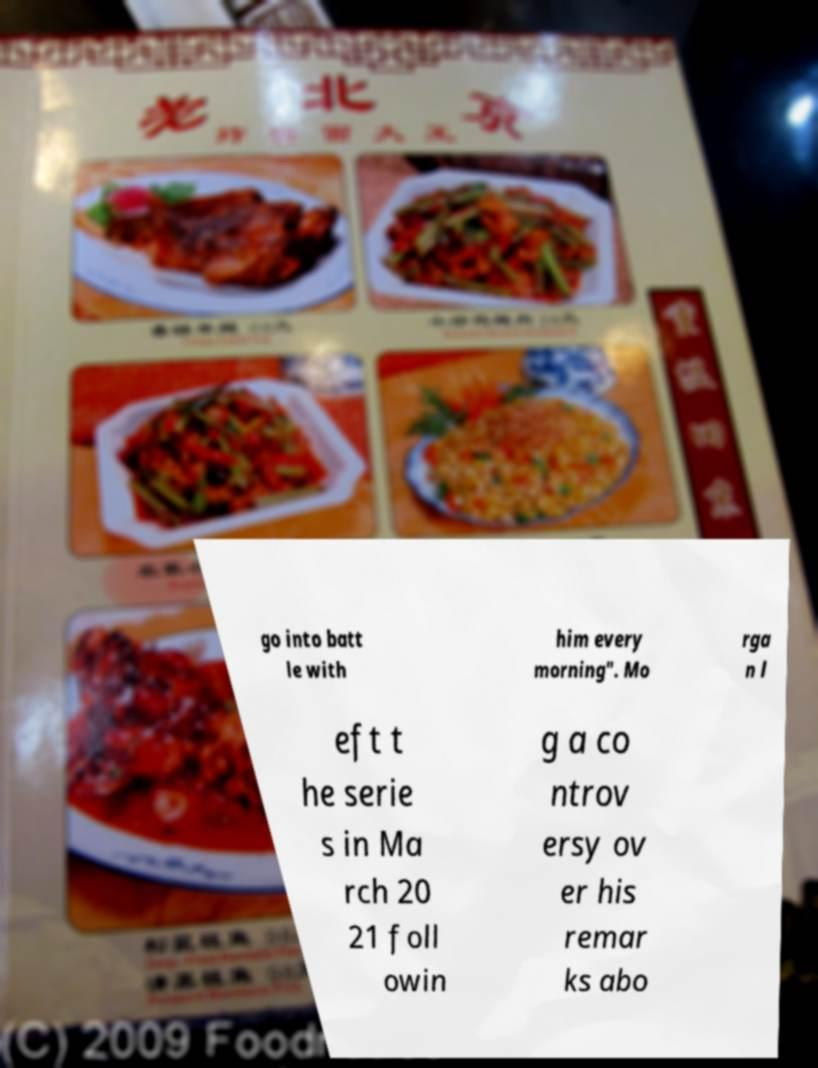Can you accurately transcribe the text from the provided image for me? go into batt le with him every morning". Mo rga n l eft t he serie s in Ma rch 20 21 foll owin g a co ntrov ersy ov er his remar ks abo 